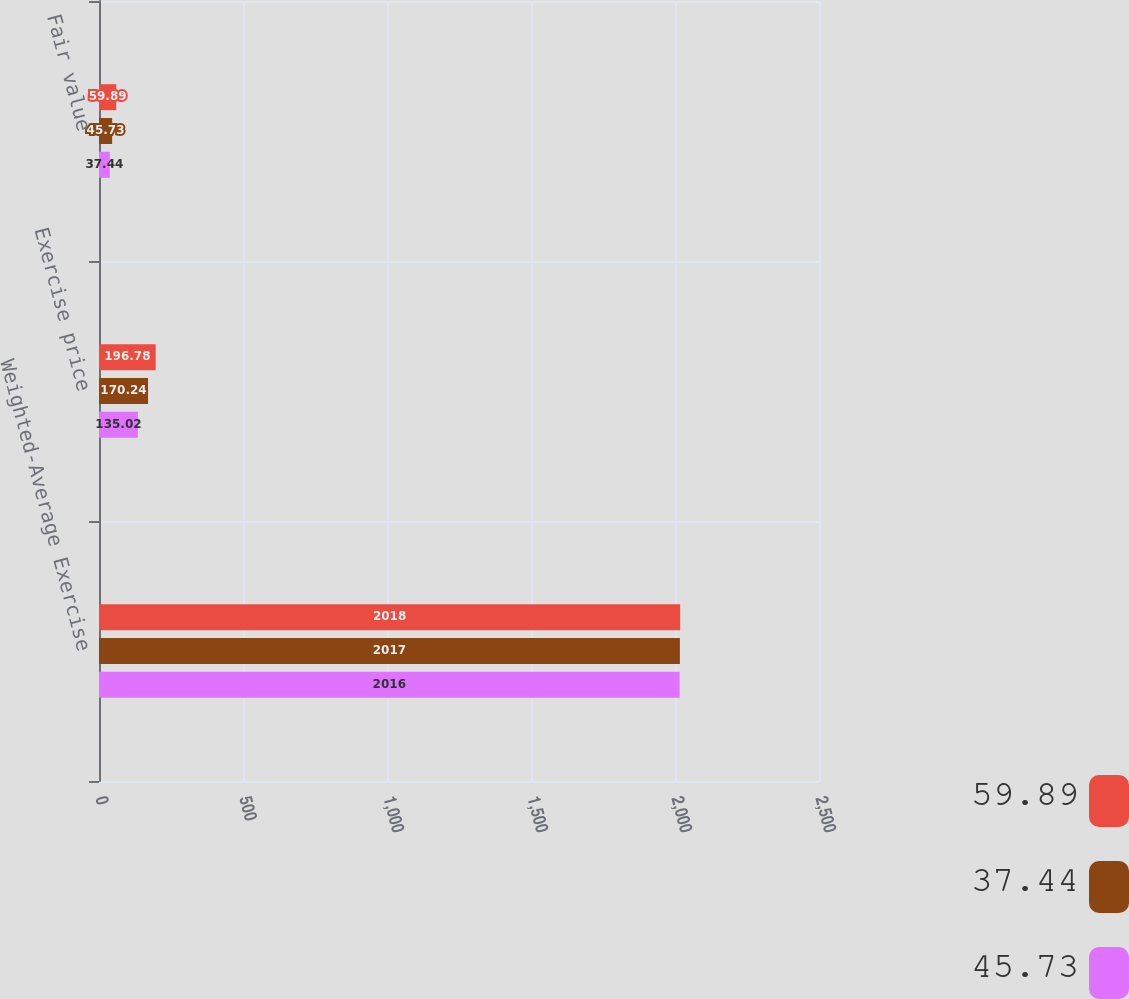<chart> <loc_0><loc_0><loc_500><loc_500><stacked_bar_chart><ecel><fcel>Weighted-Average Exercise<fcel>Exercise price<fcel>Fair value<nl><fcel>59.89<fcel>2018<fcel>196.78<fcel>59.89<nl><fcel>37.44<fcel>2017<fcel>170.24<fcel>45.73<nl><fcel>45.73<fcel>2016<fcel>135.02<fcel>37.44<nl></chart> 